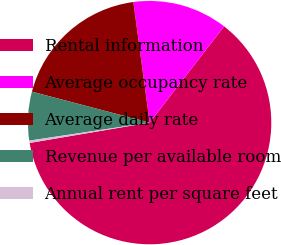Convert chart. <chart><loc_0><loc_0><loc_500><loc_500><pie_chart><fcel>Rental information<fcel>Average occupancy rate<fcel>Average daily rate<fcel>Revenue per available room<fcel>Annual rent per square feet<nl><fcel>61.84%<fcel>12.62%<fcel>18.77%<fcel>6.46%<fcel>0.31%<nl></chart> 